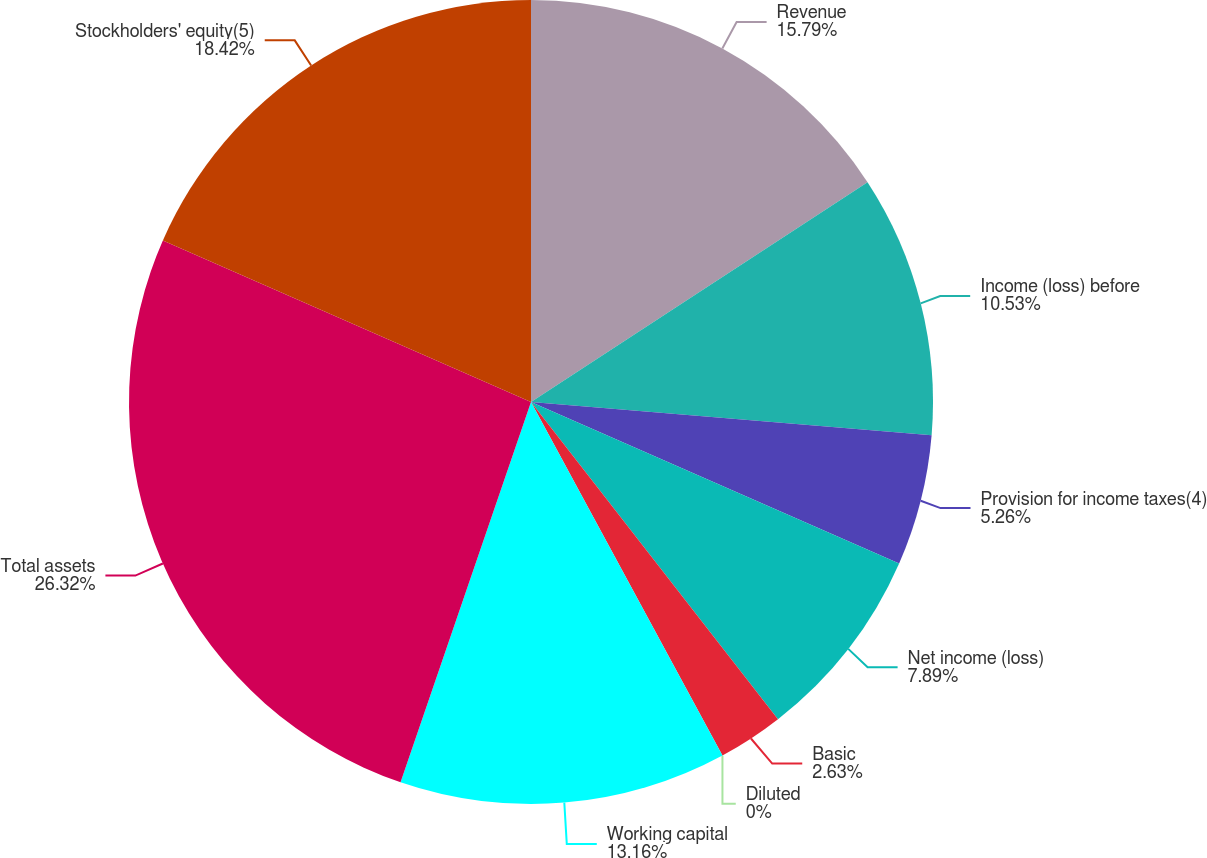Convert chart. <chart><loc_0><loc_0><loc_500><loc_500><pie_chart><fcel>Revenue<fcel>Income (loss) before<fcel>Provision for income taxes(4)<fcel>Net income (loss)<fcel>Basic<fcel>Diluted<fcel>Working capital<fcel>Total assets<fcel>Stockholders' equity(5)<nl><fcel>15.79%<fcel>10.53%<fcel>5.26%<fcel>7.89%<fcel>2.63%<fcel>0.0%<fcel>13.16%<fcel>26.32%<fcel>18.42%<nl></chart> 